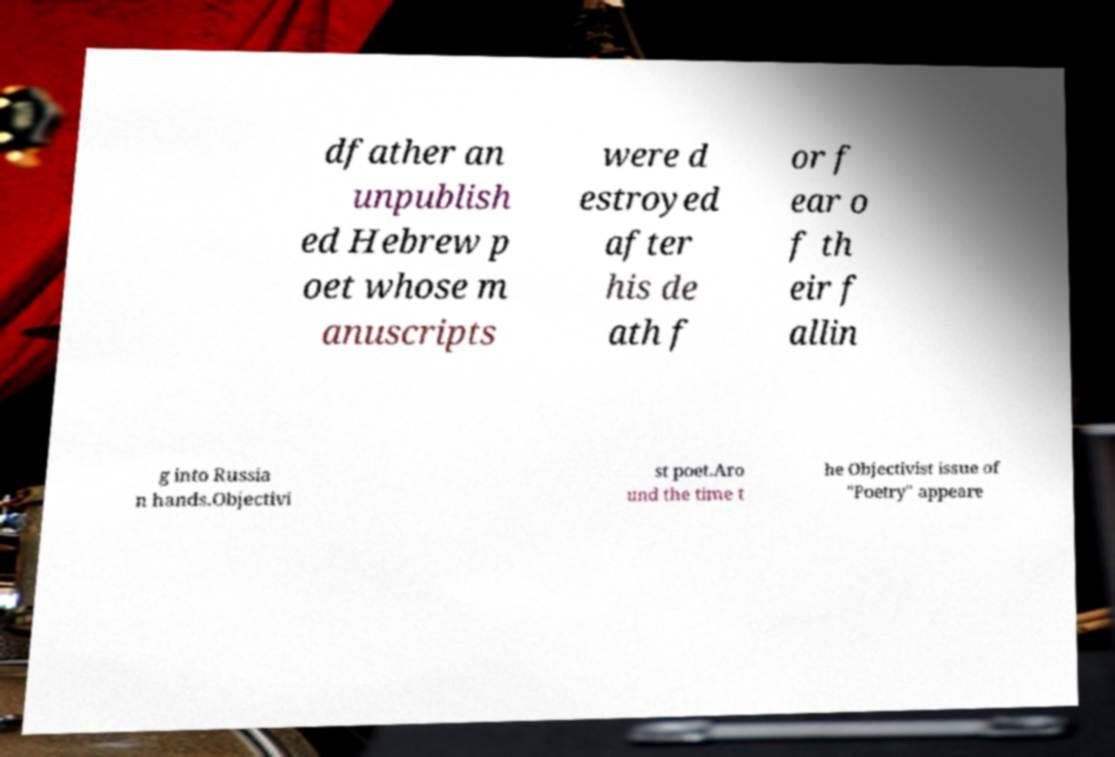Can you accurately transcribe the text from the provided image for me? dfather an unpublish ed Hebrew p oet whose m anuscripts were d estroyed after his de ath f or f ear o f th eir f allin g into Russia n hands.Objectivi st poet.Aro und the time t he Objectivist issue of "Poetry" appeare 